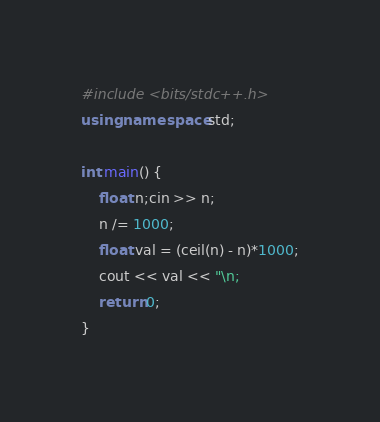Convert code to text. <code><loc_0><loc_0><loc_500><loc_500><_C++_>#include <bits/stdc++.h>
using namespace std;

int main() {
	float n;cin >> n;
	n /= 1000;
	float val = (ceil(n) - n)*1000;
	cout << val << "\n;
	return 0;
}</code> 